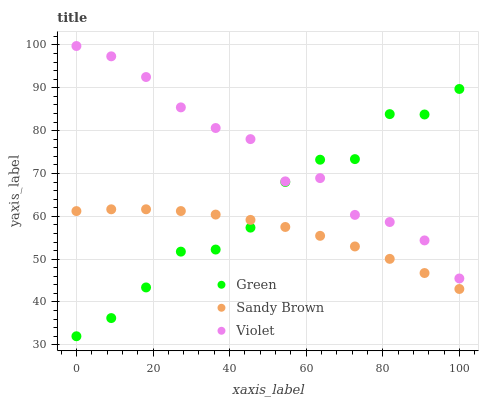Does Sandy Brown have the minimum area under the curve?
Answer yes or no. Yes. Does Violet have the maximum area under the curve?
Answer yes or no. Yes. Does Green have the minimum area under the curve?
Answer yes or no. No. Does Green have the maximum area under the curve?
Answer yes or no. No. Is Sandy Brown the smoothest?
Answer yes or no. Yes. Is Green the roughest?
Answer yes or no. Yes. Is Violet the smoothest?
Answer yes or no. No. Is Violet the roughest?
Answer yes or no. No. Does Green have the lowest value?
Answer yes or no. Yes. Does Violet have the lowest value?
Answer yes or no. No. Does Violet have the highest value?
Answer yes or no. Yes. Does Green have the highest value?
Answer yes or no. No. Is Sandy Brown less than Violet?
Answer yes or no. Yes. Is Violet greater than Sandy Brown?
Answer yes or no. Yes. Does Green intersect Sandy Brown?
Answer yes or no. Yes. Is Green less than Sandy Brown?
Answer yes or no. No. Is Green greater than Sandy Brown?
Answer yes or no. No. Does Sandy Brown intersect Violet?
Answer yes or no. No. 